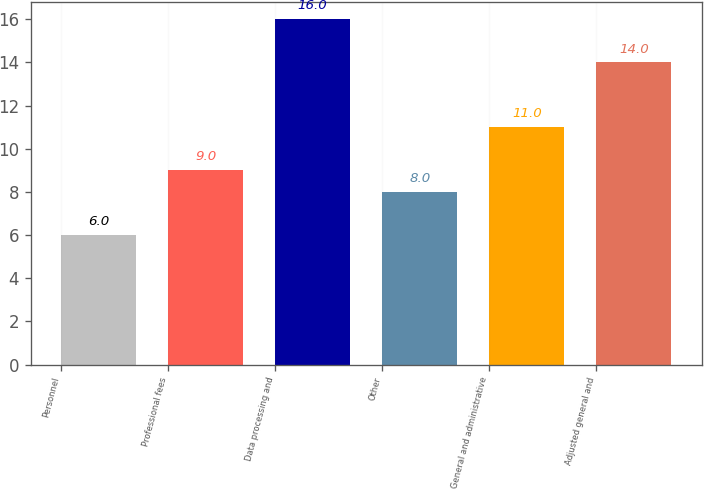Convert chart. <chart><loc_0><loc_0><loc_500><loc_500><bar_chart><fcel>Personnel<fcel>Professional fees<fcel>Data processing and<fcel>Other<fcel>General and administrative<fcel>Adjusted general and<nl><fcel>6<fcel>9<fcel>16<fcel>8<fcel>11<fcel>14<nl></chart> 